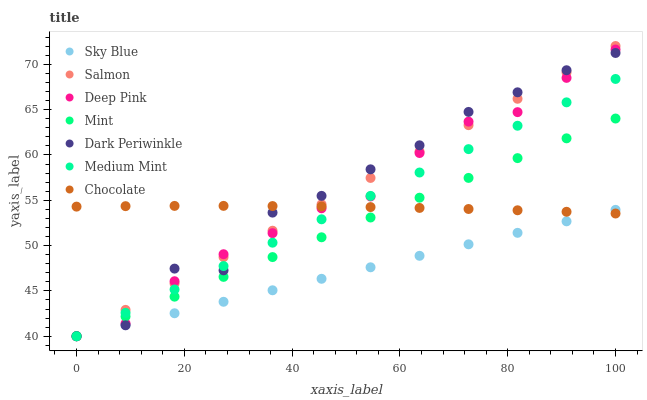Does Sky Blue have the minimum area under the curve?
Answer yes or no. Yes. Does Dark Periwinkle have the maximum area under the curve?
Answer yes or no. Yes. Does Deep Pink have the minimum area under the curve?
Answer yes or no. No. Does Deep Pink have the maximum area under the curve?
Answer yes or no. No. Is Salmon the smoothest?
Answer yes or no. Yes. Is Dark Periwinkle the roughest?
Answer yes or no. Yes. Is Deep Pink the smoothest?
Answer yes or no. No. Is Deep Pink the roughest?
Answer yes or no. No. Does Medium Mint have the lowest value?
Answer yes or no. Yes. Does Chocolate have the lowest value?
Answer yes or no. No. Does Salmon have the highest value?
Answer yes or no. Yes. Does Deep Pink have the highest value?
Answer yes or no. No. Does Sky Blue intersect Deep Pink?
Answer yes or no. Yes. Is Sky Blue less than Deep Pink?
Answer yes or no. No. Is Sky Blue greater than Deep Pink?
Answer yes or no. No. 